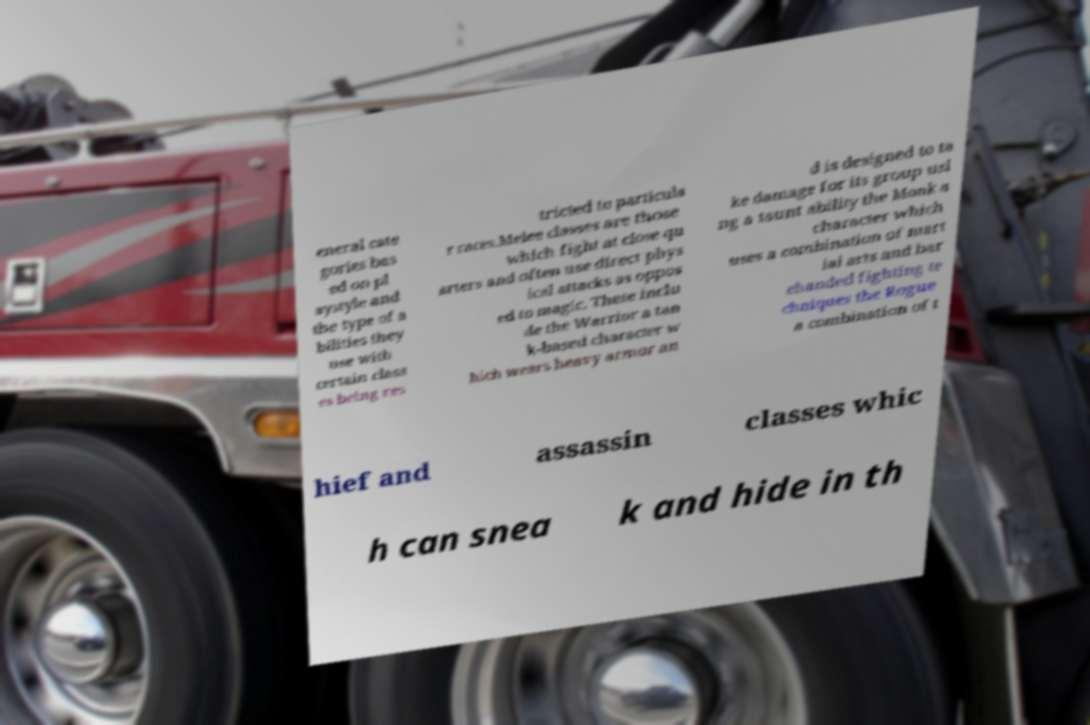Can you read and provide the text displayed in the image?This photo seems to have some interesting text. Can you extract and type it out for me? eneral cate gories bas ed on pl aystyle and the type of a bilities they use with certain class es being res tricted to particula r races.Melee classes are those which fight at close qu arters and often use direct phys ical attacks as oppos ed to magic. These inclu de the Warrior a tan k-based character w hich wears heavy armor an d is designed to ta ke damage for its group usi ng a taunt ability the Monk a character which uses a combination of mart ial arts and bar ehanded fighting te chniques the Rogue a combination of t hief and assassin classes whic h can snea k and hide in th 